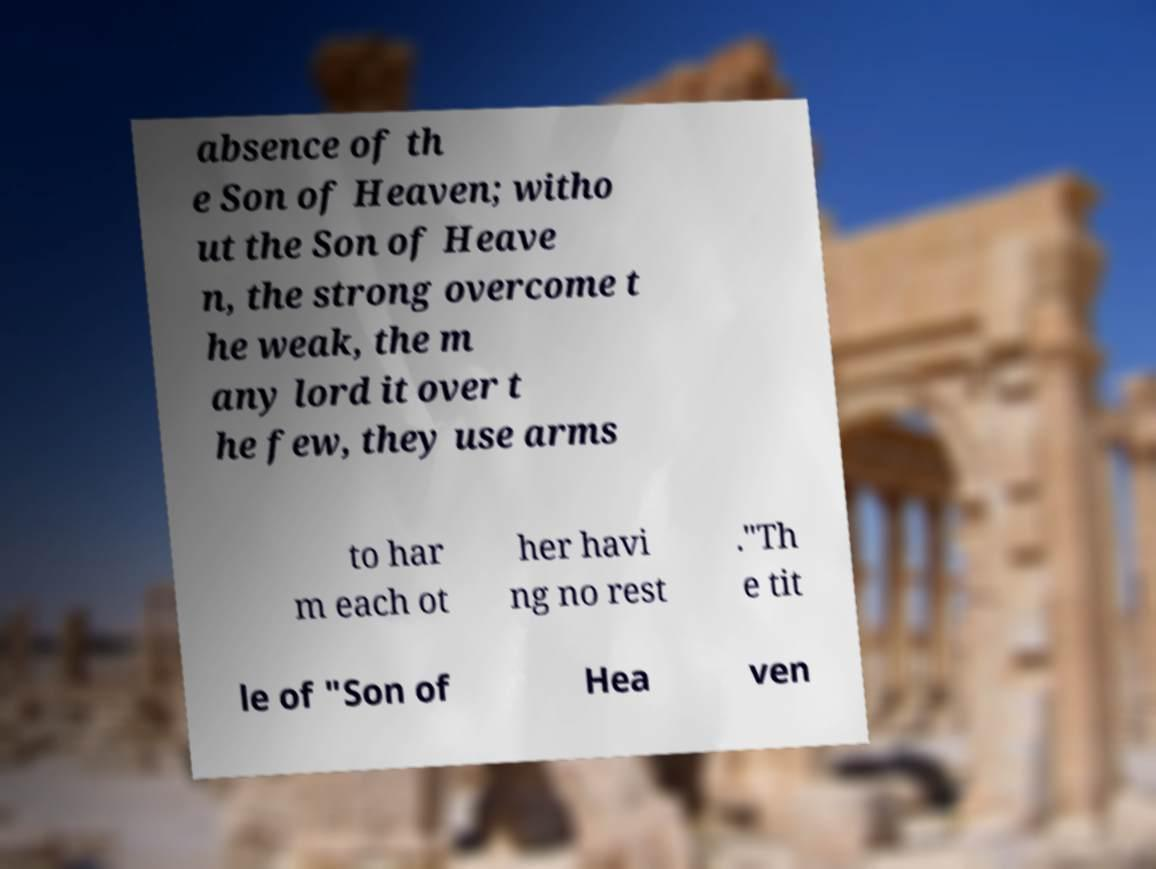For documentation purposes, I need the text within this image transcribed. Could you provide that? absence of th e Son of Heaven; witho ut the Son of Heave n, the strong overcome t he weak, the m any lord it over t he few, they use arms to har m each ot her havi ng no rest ."Th e tit le of "Son of Hea ven 